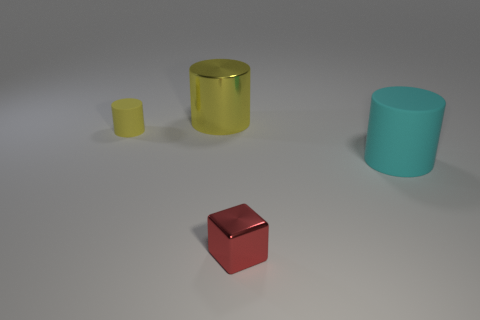What is the color of the other thing that is the same size as the yellow matte thing?
Keep it short and to the point. Red. Is there a cylinder of the same color as the small shiny thing?
Ensure brevity in your answer.  No. Are any tiny blue rubber cylinders visible?
Give a very brief answer. No. Are the big cylinder that is in front of the big yellow metal cylinder and the large yellow object made of the same material?
Your answer should be very brief. No. There is a metal thing that is the same color as the tiny rubber cylinder; what size is it?
Ensure brevity in your answer.  Large. How many red cubes have the same size as the yellow shiny thing?
Offer a very short reply. 0. Are there the same number of big matte objects behind the yellow metal cylinder and tiny shiny spheres?
Give a very brief answer. Yes. How many things are both in front of the small yellow rubber object and left of the cyan cylinder?
Your answer should be very brief. 1. The object that is the same material as the cube is what size?
Give a very brief answer. Large. What number of other things are the same shape as the large cyan rubber object?
Offer a very short reply. 2. 